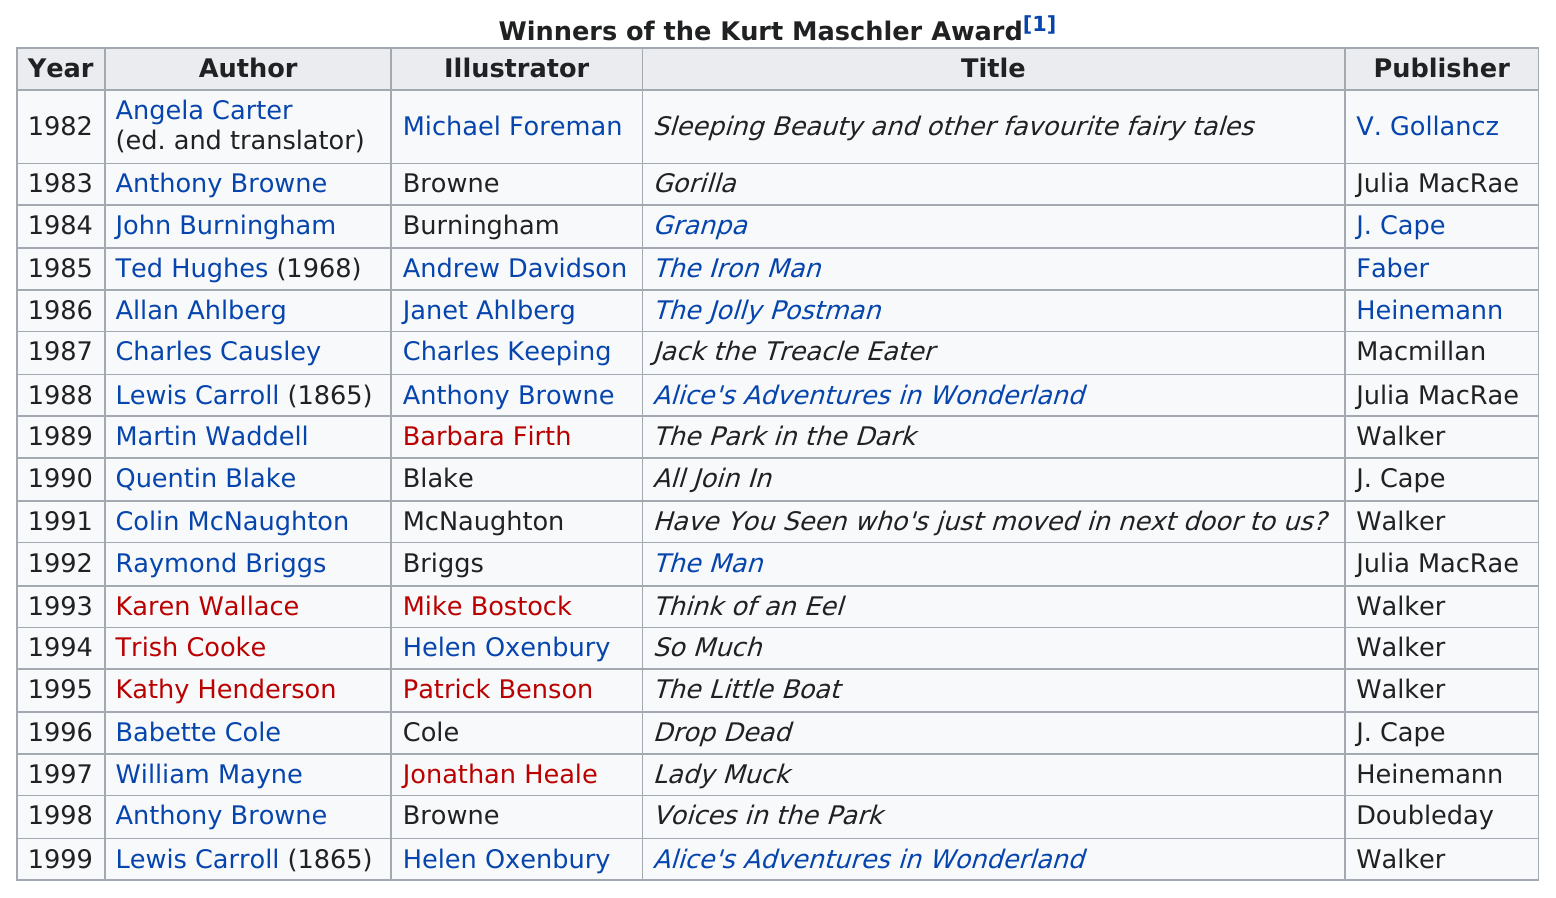Indicate a few pertinent items in this graphic. Alice's Adventures in Wonderland, which won the award a total of two times, is the book that won the award. The title of the movie was released after the year 1991 but before the year 1993. Seven titles had the same author listed as the illustrator. Helen Oxenbury has won two Kurt Maschler Awards. The illustrator responsible for the most recent award winner is Helen Oxenbury. 